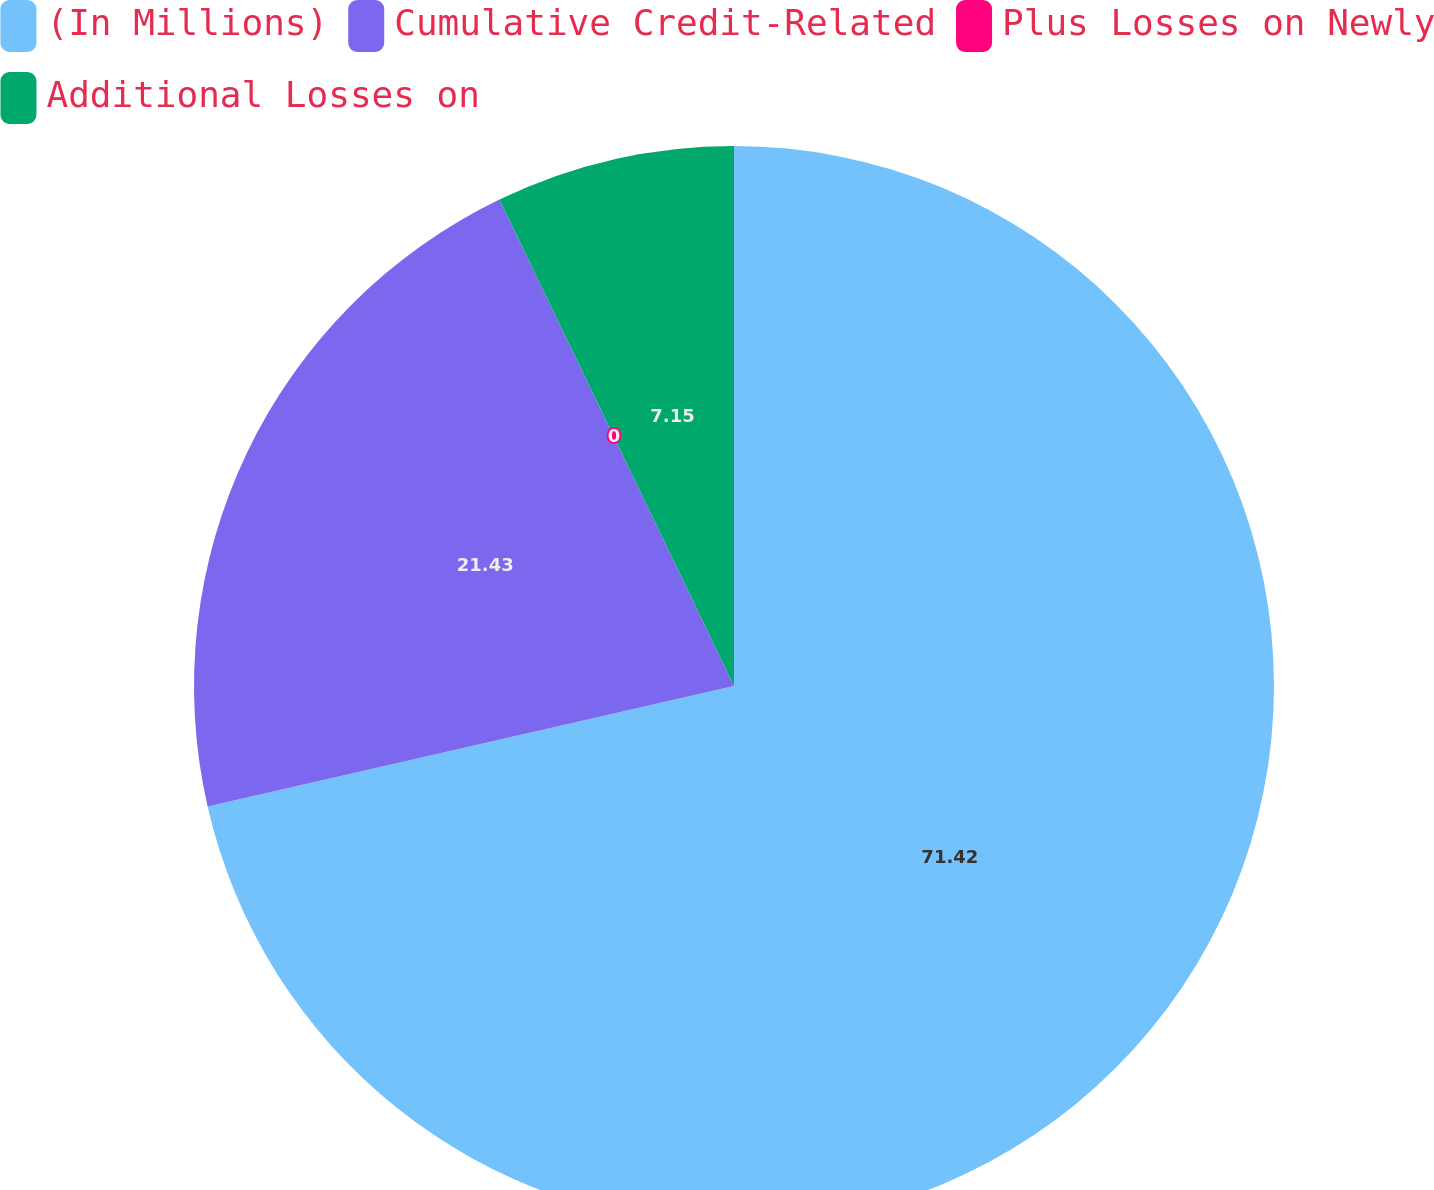<chart> <loc_0><loc_0><loc_500><loc_500><pie_chart><fcel>(In Millions)<fcel>Cumulative Credit-Related<fcel>Plus Losses on Newly<fcel>Additional Losses on<nl><fcel>71.42%<fcel>21.43%<fcel>0.0%<fcel>7.15%<nl></chart> 